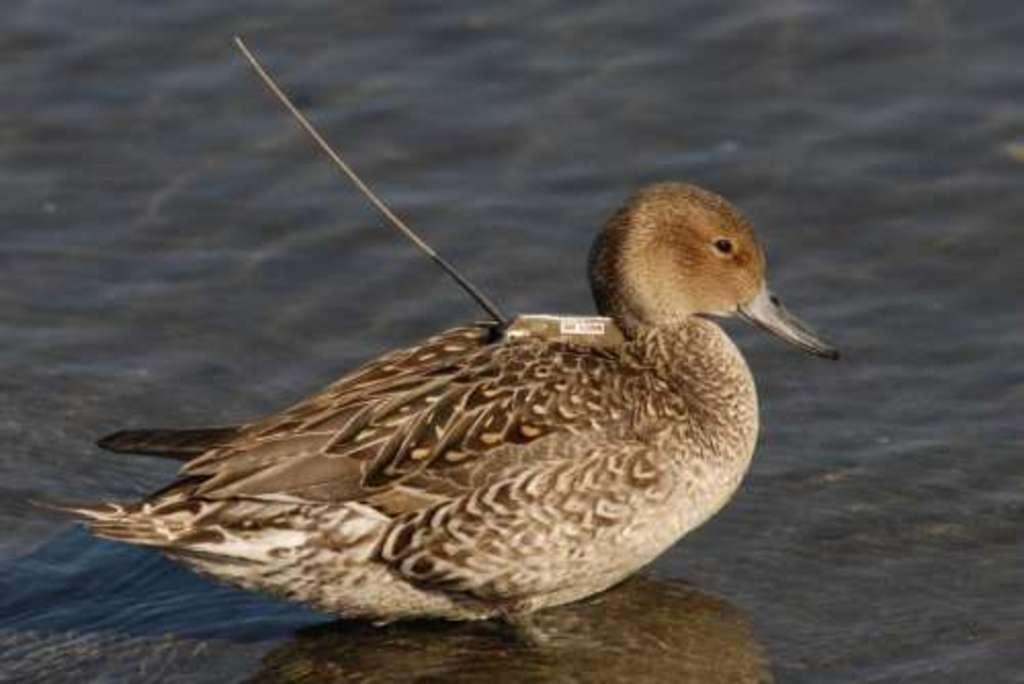How would you summarize this image in a sentence or two? In this image in the front there is a bird. In the background there is water. 